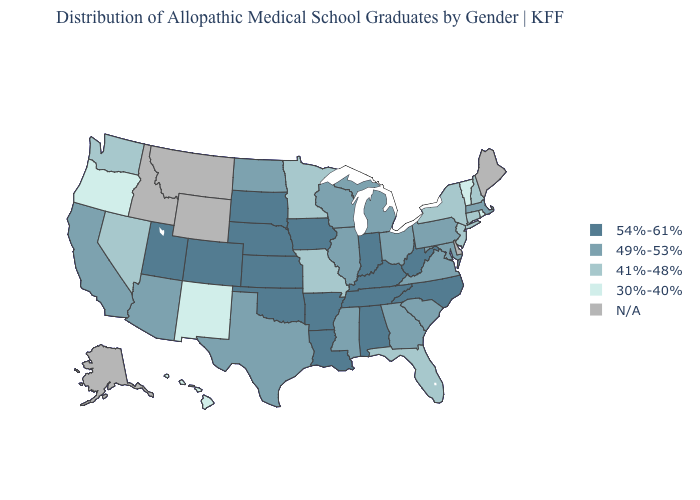Does Florida have the lowest value in the South?
Give a very brief answer. Yes. What is the value of Florida?
Keep it brief. 41%-48%. What is the highest value in the USA?
Be succinct. 54%-61%. Name the states that have a value in the range 41%-48%?
Give a very brief answer. Connecticut, Florida, Minnesota, Missouri, Nevada, New Hampshire, New Jersey, New York, Washington. Does the map have missing data?
Quick response, please. Yes. What is the highest value in the USA?
Concise answer only. 54%-61%. How many symbols are there in the legend?
Short answer required. 5. Name the states that have a value in the range N/A?
Quick response, please. Alaska, Delaware, Idaho, Maine, Montana, Wyoming. Name the states that have a value in the range 41%-48%?
Give a very brief answer. Connecticut, Florida, Minnesota, Missouri, Nevada, New Hampshire, New Jersey, New York, Washington. Does Florida have the lowest value in the South?
Keep it brief. Yes. What is the value of Wyoming?
Answer briefly. N/A. Among the states that border Indiana , which have the lowest value?
Concise answer only. Illinois, Michigan, Ohio. Name the states that have a value in the range 41%-48%?
Quick response, please. Connecticut, Florida, Minnesota, Missouri, Nevada, New Hampshire, New Jersey, New York, Washington. Among the states that border Connecticut , which have the highest value?
Concise answer only. Massachusetts. 